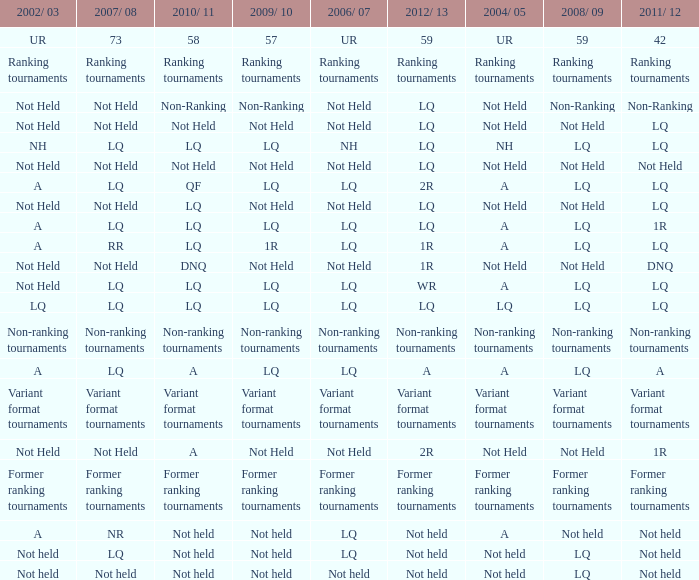Name the 2011/12 with 2008/09 of not held with 2010/11 of not held LQ, Not Held, Not held. 